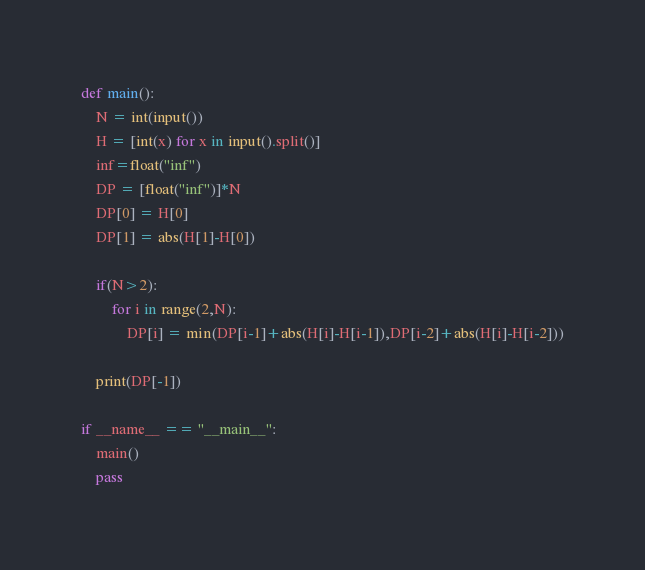Convert code to text. <code><loc_0><loc_0><loc_500><loc_500><_Python_>
def main():
    N = int(input())
    H = [int(x) for x in input().split()]
    inf=float("inf")
    DP = [float("inf")]*N
    DP[0] = H[0]
    DP[1] = abs(H[1]-H[0])

    if(N>2):
        for i in range(2,N):
            DP[i] = min(DP[i-1]+abs(H[i]-H[i-1]),DP[i-2]+abs(H[i]-H[i-2]))
    
    print(DP[-1])

if __name__ == "__main__":
    main()
    pass</code> 